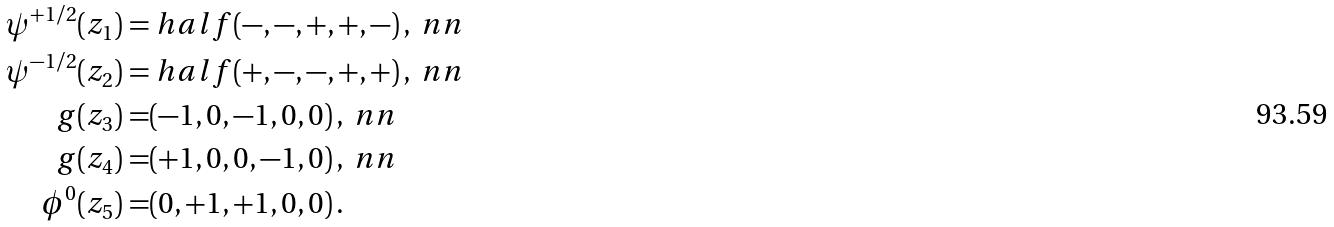<formula> <loc_0><loc_0><loc_500><loc_500>\psi ^ { + 1 / 2 } ( z _ { 1 } ) = & \ h a l f ( - , - , + , + , - ) \, , \ n n \\ \psi ^ { - 1 / 2 } ( z _ { 2 } ) = & \ h a l f ( + , - , - , + , + ) \, , \ n n \\ g ( z _ { 3 } ) = & ( - 1 , 0 , - 1 , 0 , 0 ) \, , \ n n \\ g ( z _ { 4 } ) = & ( + 1 , 0 , 0 , - 1 , 0 ) \, , \ n n \\ \phi ^ { 0 } ( z _ { 5 } ) = & ( 0 , + 1 , + 1 , 0 , 0 ) \, .</formula> 